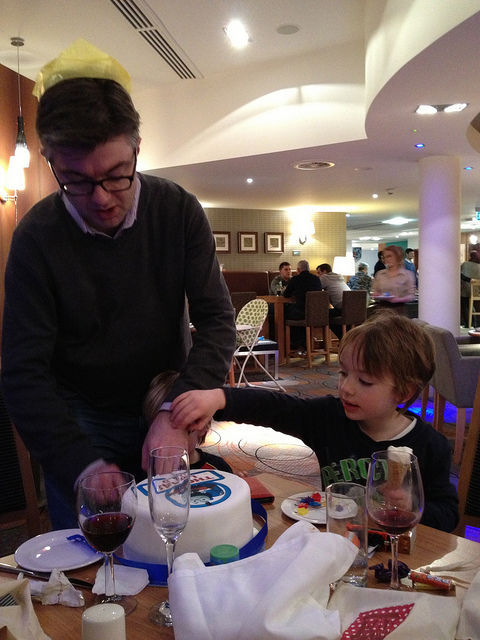Extract all visible text content from this image. iu 